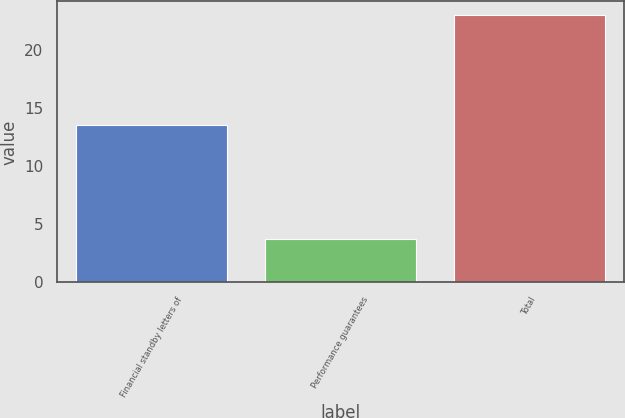<chart> <loc_0><loc_0><loc_500><loc_500><bar_chart><fcel>Financial standby letters of<fcel>Performance guarantees<fcel>Total<nl><fcel>13.5<fcel>3.7<fcel>23<nl></chart> 